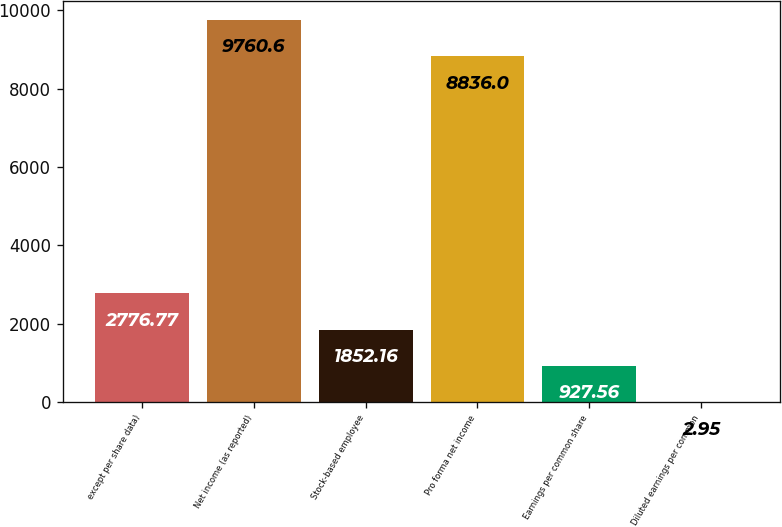Convert chart to OTSL. <chart><loc_0><loc_0><loc_500><loc_500><bar_chart><fcel>except per share data)<fcel>Net income (as reported)<fcel>Stock-based employee<fcel>Pro forma net income<fcel>Earnings per common share<fcel>Diluted earnings per common<nl><fcel>2776.77<fcel>9760.6<fcel>1852.16<fcel>8836<fcel>927.56<fcel>2.95<nl></chart> 